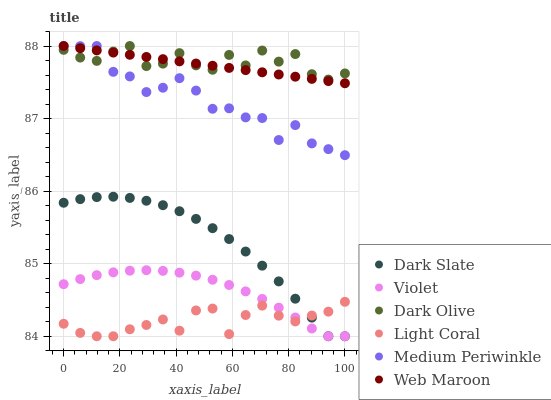Does Light Coral have the minimum area under the curve?
Answer yes or no. Yes. Does Dark Olive have the maximum area under the curve?
Answer yes or no. Yes. Does Medium Periwinkle have the minimum area under the curve?
Answer yes or no. No. Does Medium Periwinkle have the maximum area under the curve?
Answer yes or no. No. Is Web Maroon the smoothest?
Answer yes or no. Yes. Is Dark Olive the roughest?
Answer yes or no. Yes. Is Medium Periwinkle the smoothest?
Answer yes or no. No. Is Medium Periwinkle the roughest?
Answer yes or no. No. Does Light Coral have the lowest value?
Answer yes or no. Yes. Does Medium Periwinkle have the lowest value?
Answer yes or no. No. Does Medium Periwinkle have the highest value?
Answer yes or no. Yes. Does Light Coral have the highest value?
Answer yes or no. No. Is Violet less than Dark Olive?
Answer yes or no. Yes. Is Web Maroon greater than Violet?
Answer yes or no. Yes. Does Dark Slate intersect Light Coral?
Answer yes or no. Yes. Is Dark Slate less than Light Coral?
Answer yes or no. No. Is Dark Slate greater than Light Coral?
Answer yes or no. No. Does Violet intersect Dark Olive?
Answer yes or no. No. 